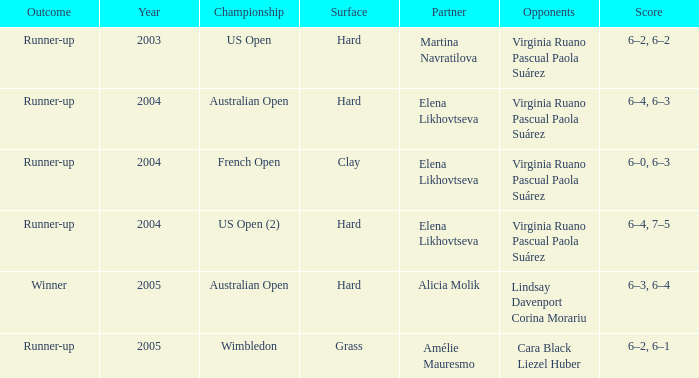In the australian open championship, what is the earliest year? 2004.0. 